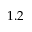<formula> <loc_0><loc_0><loc_500><loc_500>1 . 2</formula> 